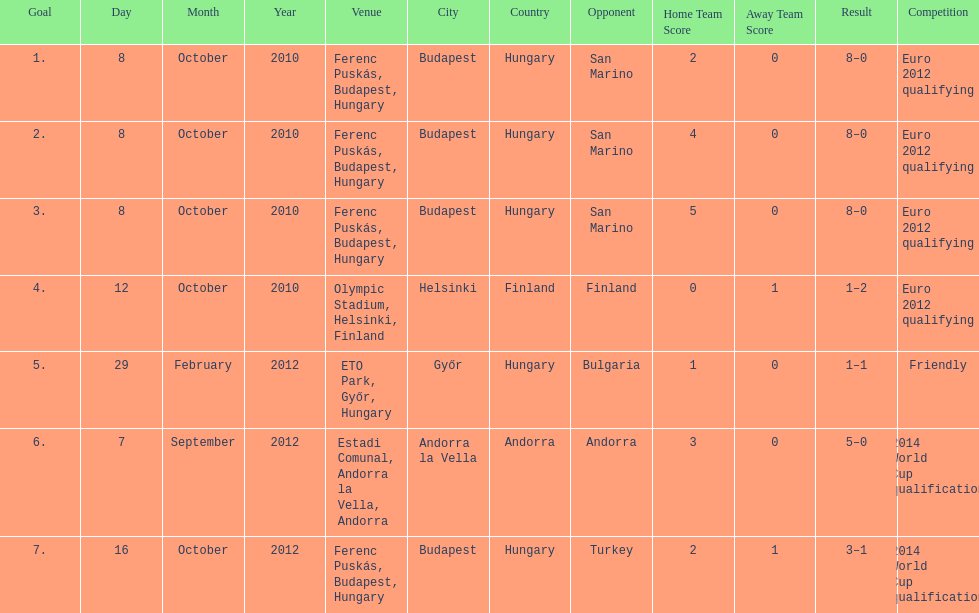Szalai scored all but one of his international goals in either euro 2012 qualifying or what other level of play? 2014 World Cup qualification. Would you mind parsing the complete table? {'header': ['Goal', 'Day', 'Month', 'Year', 'Venue', 'City', 'Country', 'Opponent', 'Home Team Score', 'Away Team Score', 'Result', 'Competition'], 'rows': [['1.', '8', 'October', '2010', 'Ferenc Puskás, Budapest, Hungary', 'Budapest', 'Hungary', 'San Marino', '2', '0', '8–0', 'Euro 2012 qualifying'], ['2.', '8', 'October', '2010', 'Ferenc Puskás, Budapest, Hungary', 'Budapest', 'Hungary', 'San Marino', '4', '0', '8–0', 'Euro 2012 qualifying'], ['3.', '8', 'October', '2010', 'Ferenc Puskás, Budapest, Hungary', 'Budapest', 'Hungary', 'San Marino', '5', '0', '8–0', 'Euro 2012 qualifying'], ['4.', '12', 'October', '2010', 'Olympic Stadium, Helsinki, Finland', 'Helsinki', 'Finland', 'Finland', '0', '1', '1–2', 'Euro 2012 qualifying'], ['5.', '29', 'February', '2012', 'ETO Park, Győr, Hungary', 'Győr', 'Hungary', 'Bulgaria', '1', '0', '1–1', 'Friendly'], ['6.', '7', 'September', '2012', 'Estadi Comunal, Andorra la Vella, Andorra', 'Andorra la Vella', 'Andorra', 'Andorra', '3', '0', '5–0', '2014 World Cup qualification'], ['7.', '16', 'October', '2012', 'Ferenc Puskás, Budapest, Hungary', 'Budapest', 'Hungary', 'Turkey', '2', '1', '3–1', '2014 World Cup qualification']]} 